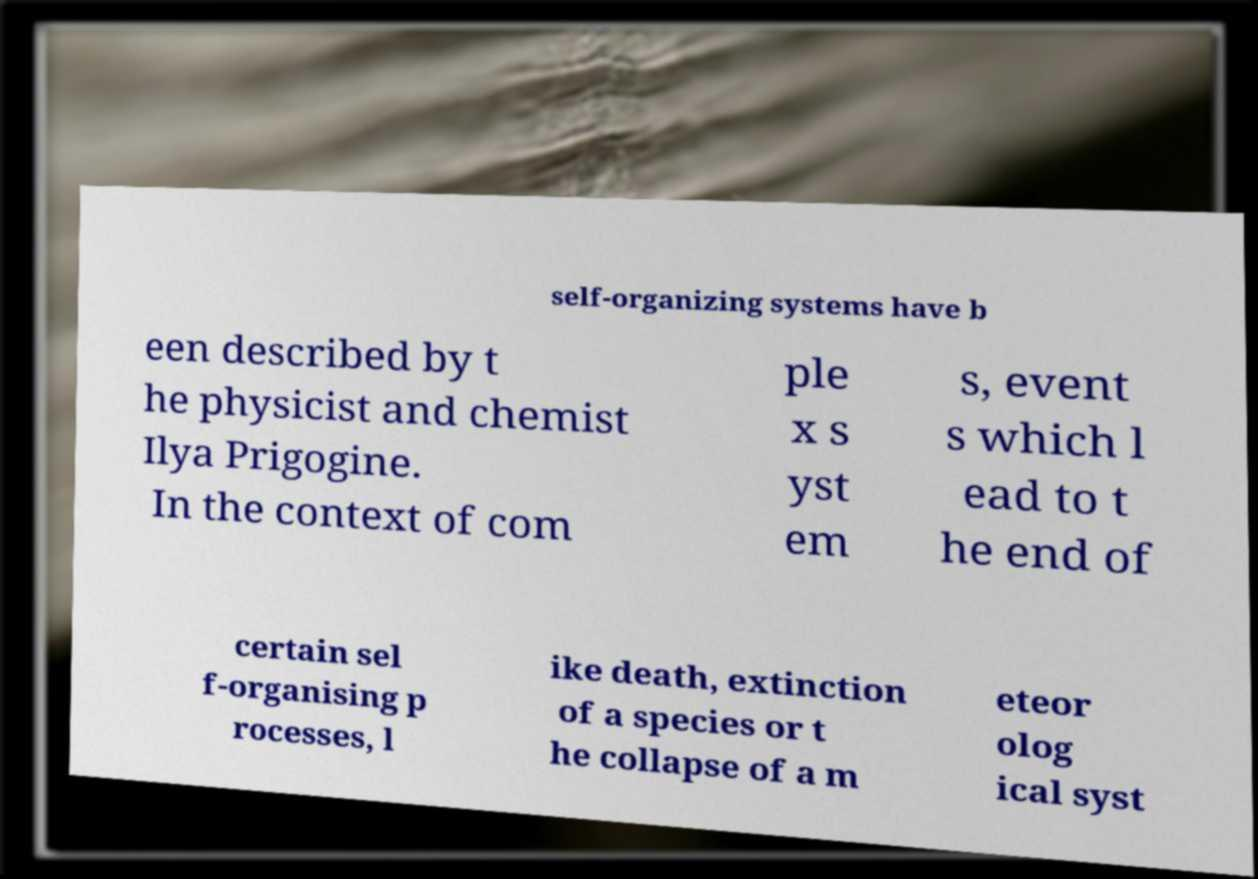Can you accurately transcribe the text from the provided image for me? self-organizing systems have b een described by t he physicist and chemist Ilya Prigogine. In the context of com ple x s yst em s, event s which l ead to t he end of certain sel f-organising p rocesses, l ike death, extinction of a species or t he collapse of a m eteor olog ical syst 